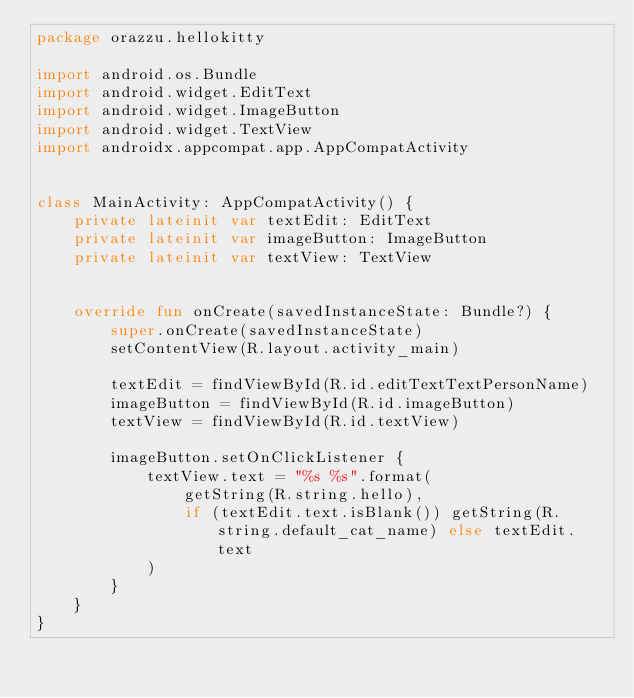<code> <loc_0><loc_0><loc_500><loc_500><_Kotlin_>package orazzu.hellokitty

import android.os.Bundle
import android.widget.EditText
import android.widget.ImageButton
import android.widget.TextView
import androidx.appcompat.app.AppCompatActivity


class MainActivity: AppCompatActivity() {
    private lateinit var textEdit: EditText
    private lateinit var imageButton: ImageButton
    private lateinit var textView: TextView


    override fun onCreate(savedInstanceState: Bundle?) {
        super.onCreate(savedInstanceState)
        setContentView(R.layout.activity_main)

        textEdit = findViewById(R.id.editTextTextPersonName)
        imageButton = findViewById(R.id.imageButton)
        textView = findViewById(R.id.textView)

        imageButton.setOnClickListener {
            textView.text = "%s %s".format(
                getString(R.string.hello),
                if (textEdit.text.isBlank()) getString(R.string.default_cat_name) else textEdit.text
            )
        }
    }
}</code> 